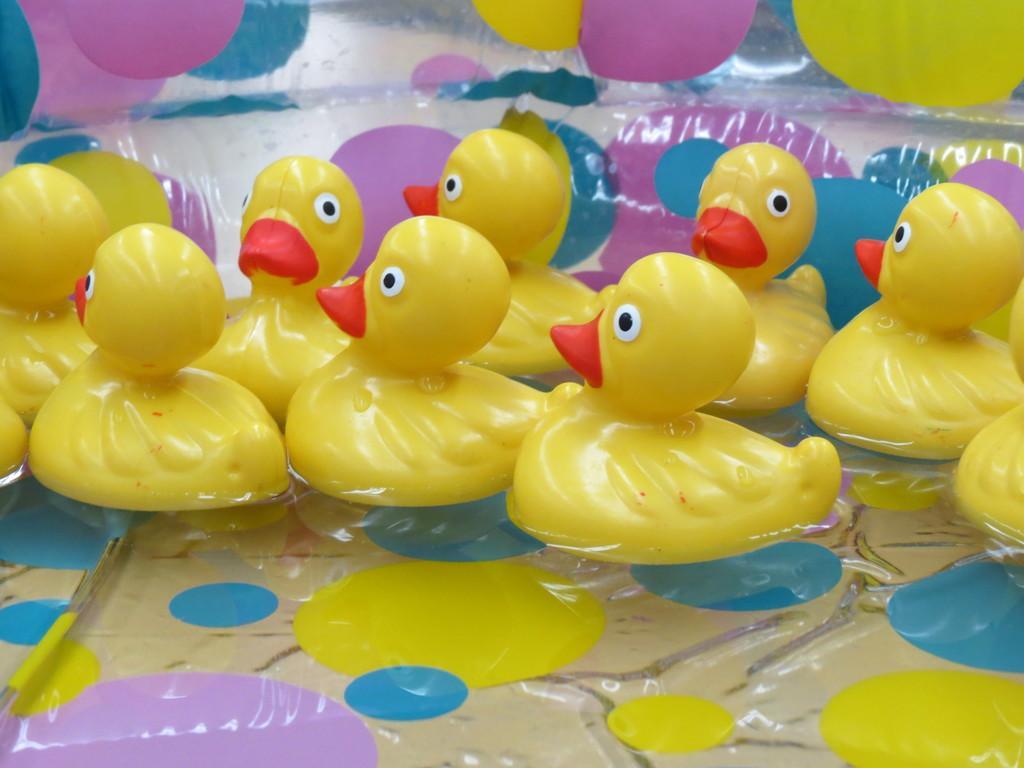Can you describe this image briefly? In this image I can see few toy ducks in the water. The ducks are in yellow color and the beaks are in red color. 